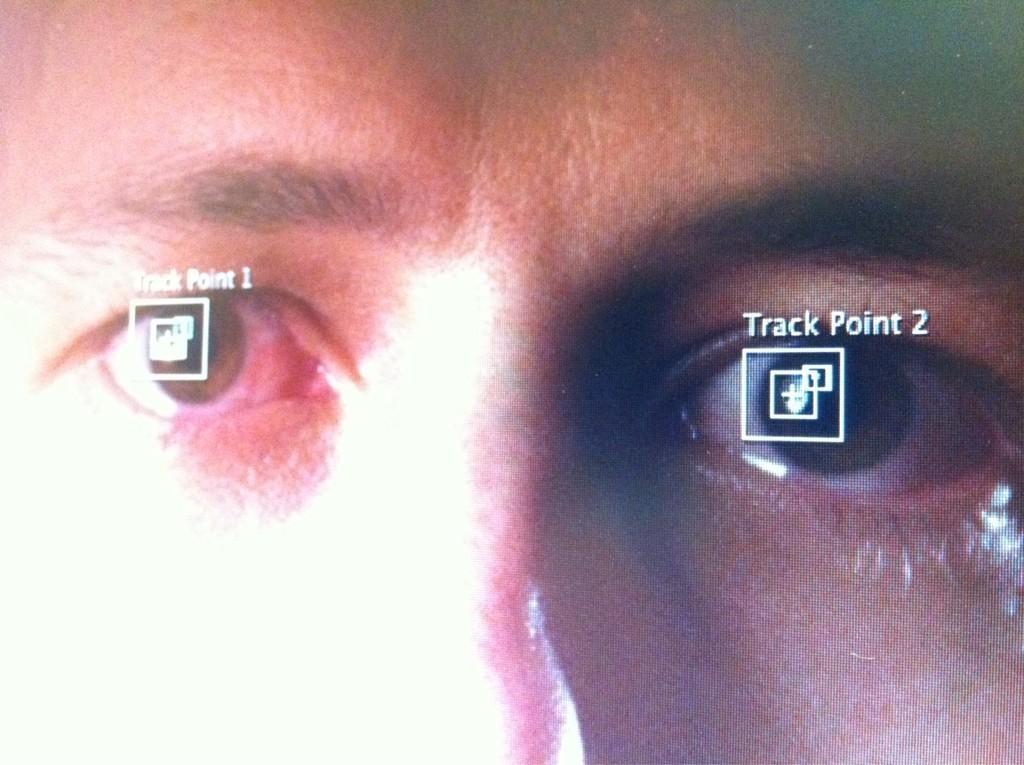Please provide a concise description of this image. In the picture I can see the screen in which I can see the person image where I can see some images and text on the eyes. 